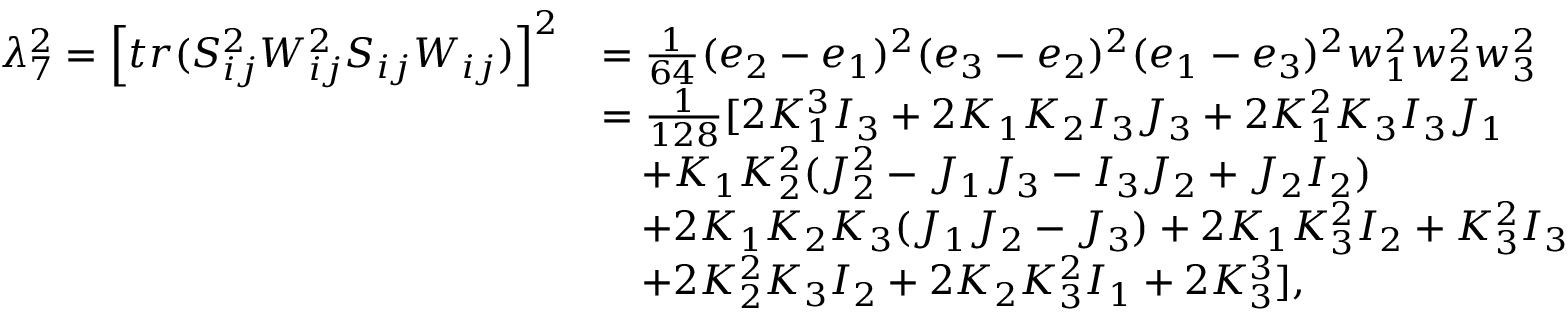Convert formula to latex. <formula><loc_0><loc_0><loc_500><loc_500>\begin{array} { r l } { \lambda _ { 7 } ^ { 2 } = \left [ t r ( S _ { i j } ^ { 2 } W _ { i j } ^ { 2 } S _ { i j } W _ { i j } ) \right ] ^ { 2 } } & { = \frac { 1 } { 6 4 } ( e _ { 2 } - e _ { 1 } ) ^ { 2 } ( e _ { 3 } - e _ { 2 } ) ^ { 2 } ( e _ { 1 } - e _ { 3 } ) ^ { 2 } w _ { 1 } ^ { 2 } w _ { 2 } ^ { 2 } w _ { 3 } ^ { 2 } } \\ & { = \frac { 1 } { 1 2 8 } [ 2 K _ { 1 } ^ { 3 } I _ { 3 } + 2 K _ { 1 } K _ { 2 } I _ { 3 } J _ { 3 } + 2 K _ { 1 } ^ { 2 } K _ { 3 } I _ { 3 } J _ { 1 } } \\ & { \quad + K _ { 1 } K _ { 2 } ^ { 2 } ( J _ { 2 } ^ { 2 } - J _ { 1 } J _ { 3 } - I _ { 3 } J _ { 2 } + J _ { 2 } I _ { 2 } ) } \\ & { \quad + 2 K _ { 1 } K _ { 2 } K _ { 3 } ( J _ { 1 } J _ { 2 } - J _ { 3 } ) + 2 K _ { 1 } K _ { 3 } ^ { 2 } I _ { 2 } + K _ { 3 } ^ { 2 } I _ { 3 } } \\ & { \quad + 2 K _ { 2 } ^ { 2 } K _ { 3 } I _ { 2 } + 2 K _ { 2 } K _ { 3 } ^ { 2 } I _ { 1 } + 2 K _ { 3 } ^ { 3 } ] , } \end{array}</formula> 